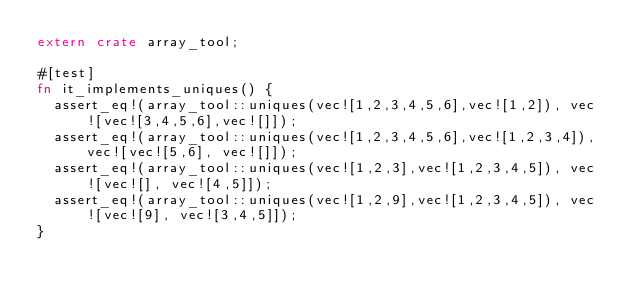<code> <loc_0><loc_0><loc_500><loc_500><_Rust_>extern crate array_tool;

#[test]
fn it_implements_uniques() {
  assert_eq!(array_tool::uniques(vec![1,2,3,4,5,6],vec![1,2]), vec![vec![3,4,5,6],vec![]]);
  assert_eq!(array_tool::uniques(vec![1,2,3,4,5,6],vec![1,2,3,4]), vec![vec![5,6], vec![]]);
  assert_eq!(array_tool::uniques(vec![1,2,3],vec![1,2,3,4,5]), vec![vec![], vec![4,5]]);
  assert_eq!(array_tool::uniques(vec![1,2,9],vec![1,2,3,4,5]), vec![vec![9], vec![3,4,5]]);
}

</code> 